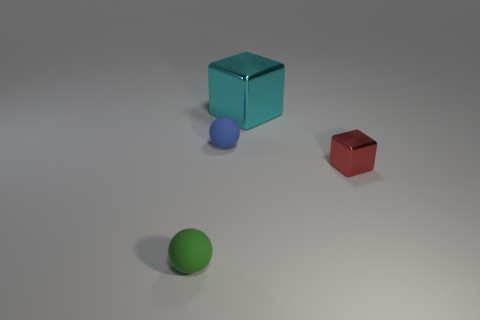Add 1 large metallic things. How many objects exist? 5 Subtract all purple shiny balls. Subtract all small green balls. How many objects are left? 3 Add 2 cyan metallic blocks. How many cyan metallic blocks are left? 3 Add 4 cyan blocks. How many cyan blocks exist? 5 Subtract 0 red cylinders. How many objects are left? 4 